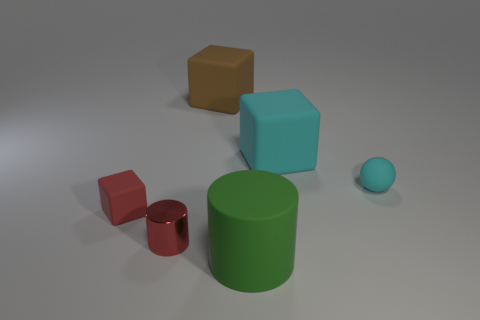Add 1 gray balls. How many objects exist? 7 Subtract all small red rubber blocks. How many blocks are left? 2 Subtract all brown blocks. How many blocks are left? 2 Subtract 0 yellow balls. How many objects are left? 6 Subtract all cylinders. How many objects are left? 4 Subtract 3 blocks. How many blocks are left? 0 Subtract all green cylinders. Subtract all yellow blocks. How many cylinders are left? 1 Subtract all green cubes. How many yellow cylinders are left? 0 Subtract all yellow rubber cylinders. Subtract all small cyan balls. How many objects are left? 5 Add 5 large cyan objects. How many large cyan objects are left? 6 